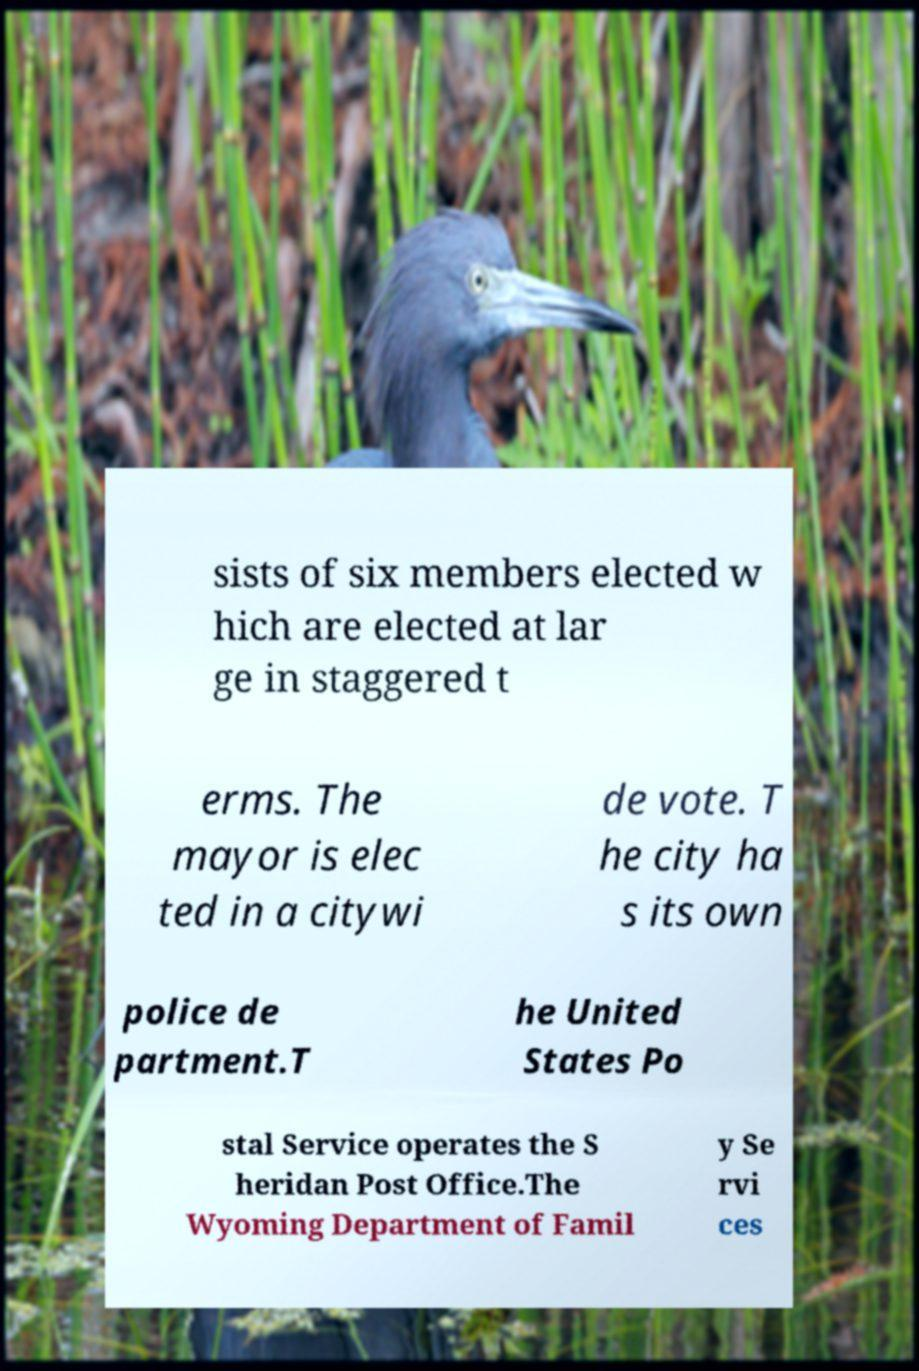Could you assist in decoding the text presented in this image and type it out clearly? sists of six members elected w hich are elected at lar ge in staggered t erms. The mayor is elec ted in a citywi de vote. T he city ha s its own police de partment.T he United States Po stal Service operates the S heridan Post Office.The Wyoming Department of Famil y Se rvi ces 